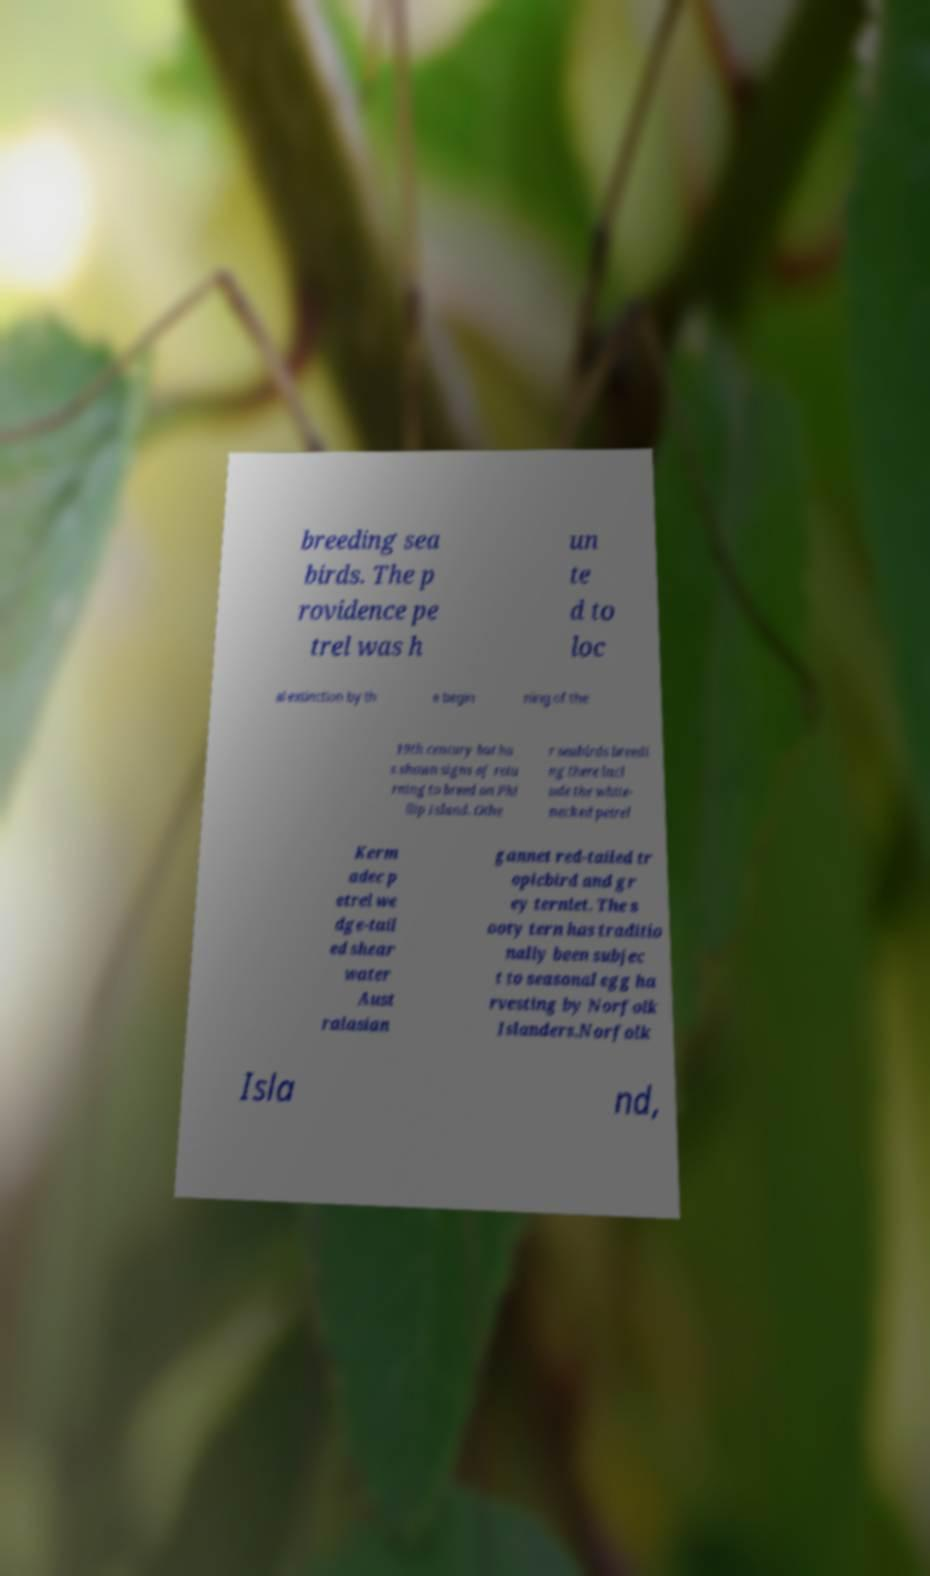There's text embedded in this image that I need extracted. Can you transcribe it verbatim? breeding sea birds. The p rovidence pe trel was h un te d to loc al extinction by th e begin ning of the 19th century but ha s shown signs of retu rning to breed on Phi llip Island. Othe r seabirds breedi ng there incl ude the white- necked petrel Kerm adec p etrel we dge-tail ed shear water Aust ralasian gannet red-tailed tr opicbird and gr ey ternlet. The s ooty tern has traditio nally been subjec t to seasonal egg ha rvesting by Norfolk Islanders.Norfolk Isla nd, 